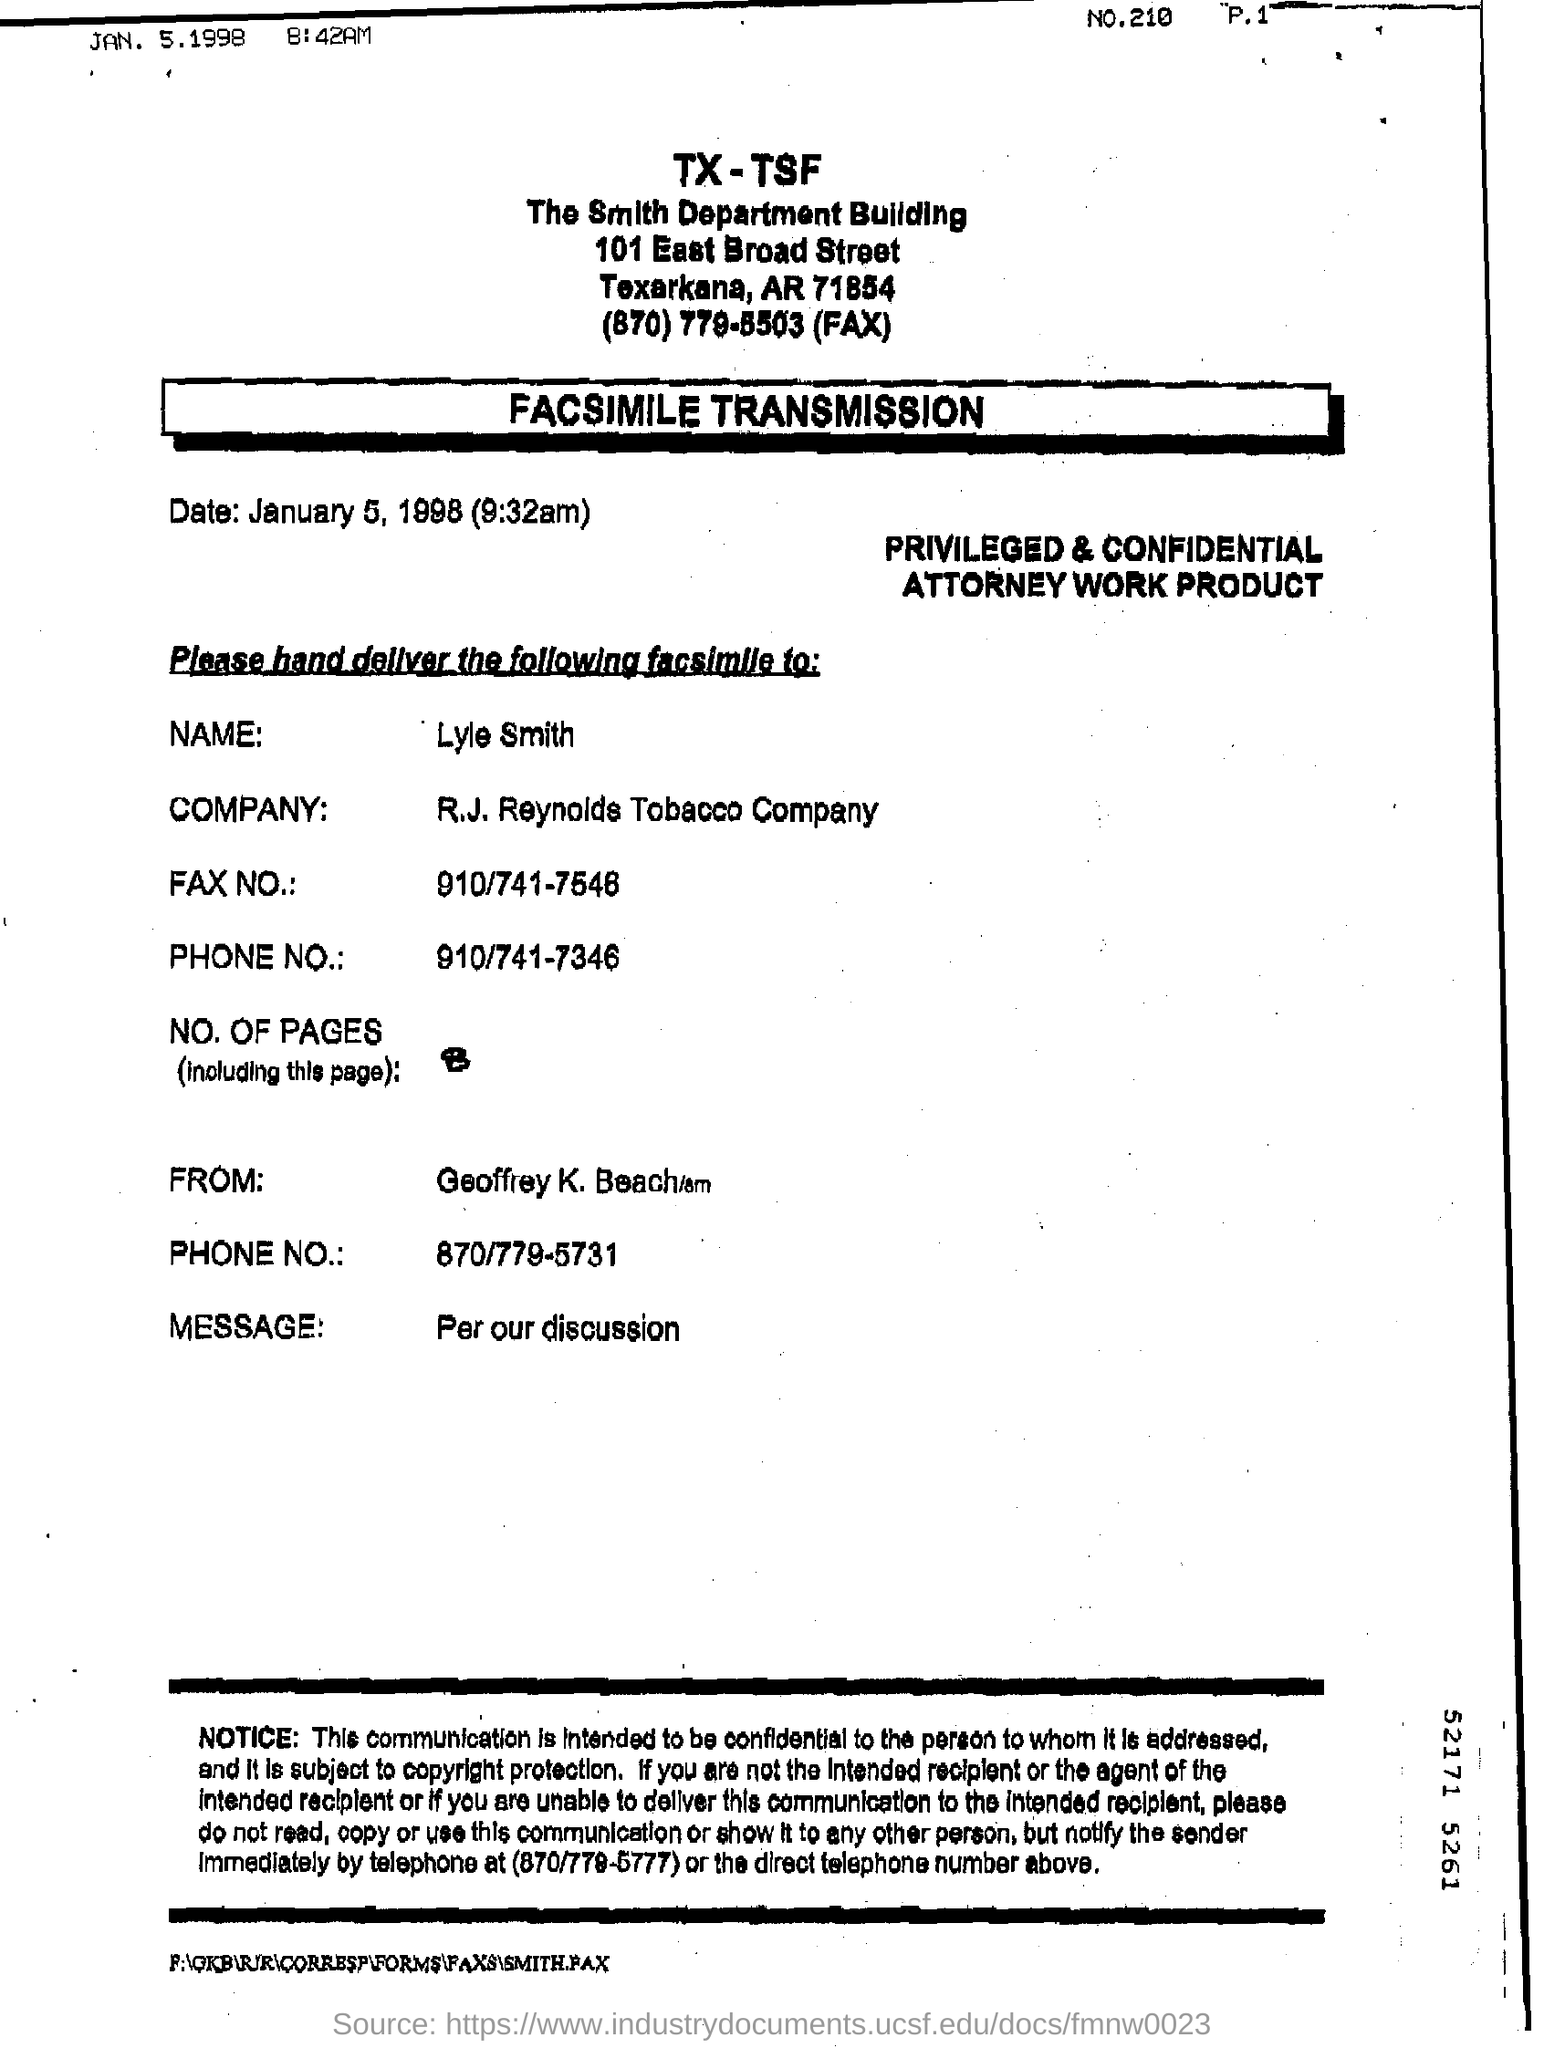What is the date mentioned?
Your answer should be very brief. January 5, 1998. To is the document addressed to?
Keep it short and to the point. LYLE SMITH. 